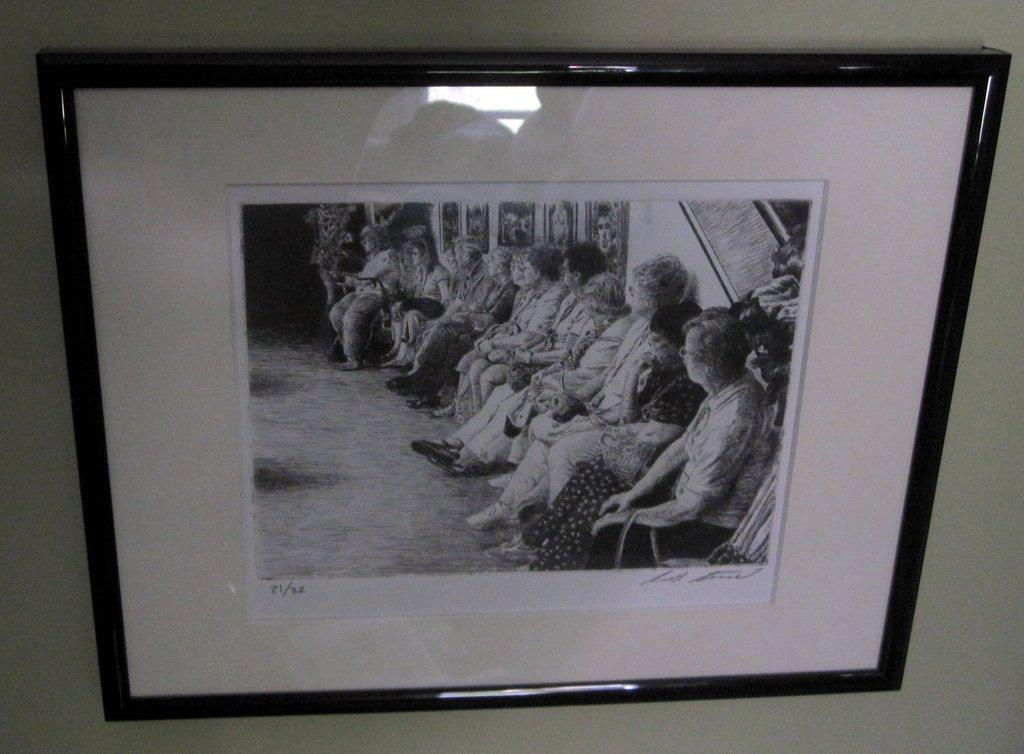How many paintings were made?
Your answer should be compact. 32. 